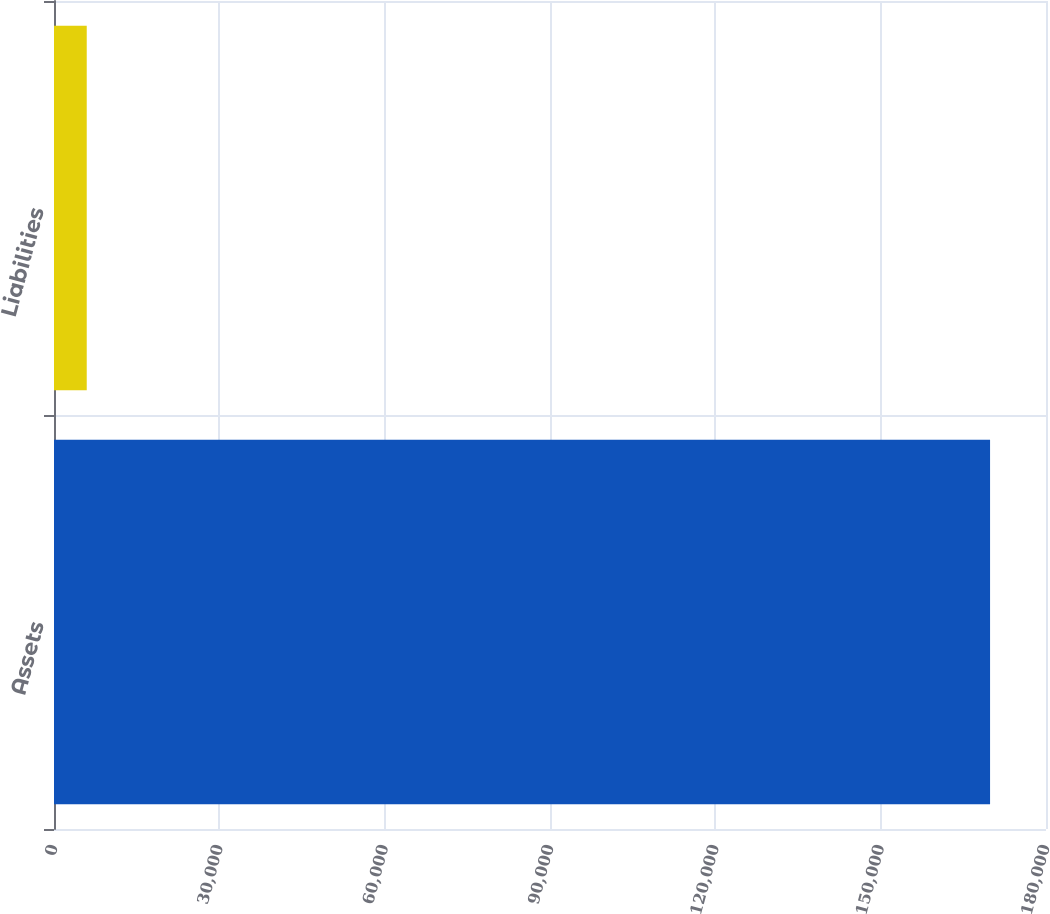Convert chart. <chart><loc_0><loc_0><loc_500><loc_500><bar_chart><fcel>Assets<fcel>Liabilities<nl><fcel>169850<fcel>5940<nl></chart> 